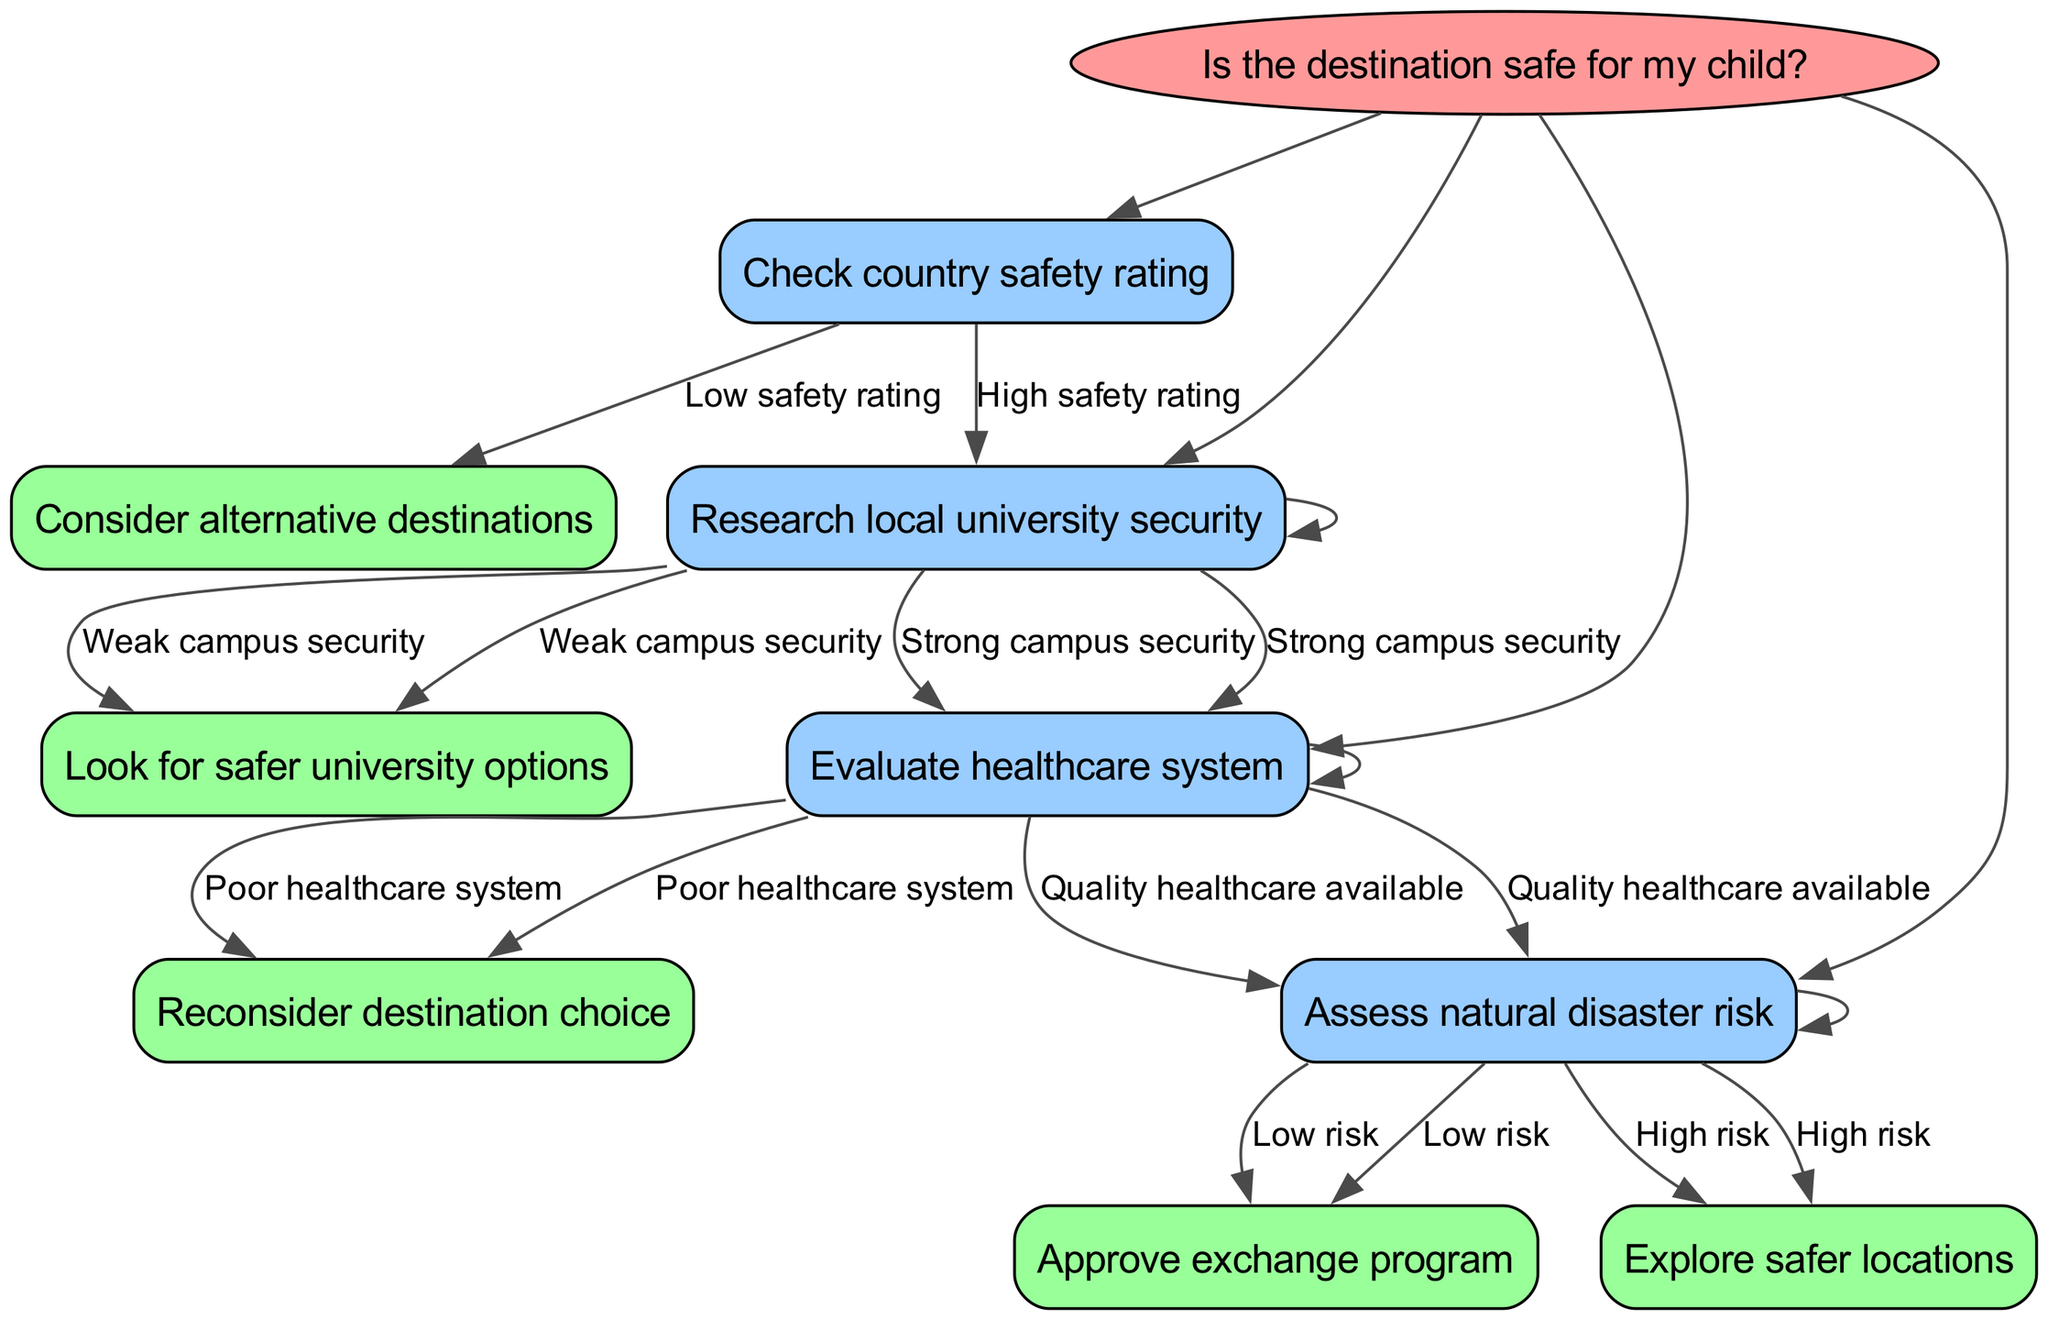What is the root node of the diagram? The root node of the diagram states, "Is the destination safe for my child?"
Answer: Is the destination safe for my child? How many branches are there from the root node? There are four branches stemming from the root node, which represent different decision points regarding safety.
Answer: Four What is the outcome if the country has a low safety rating? If the country has a low safety rating, the next node directs to "Consider alternative destinations."
Answer: Consider alternative destinations What does a strong campus security lead to in the diagram? A strong campus security leads to the next evaluation node, which is "Evaluate healthcare system."
Answer: Evaluate healthcare system What happens if the healthcare system is poor? If the healthcare system is deemed poor, the decision tree suggests "Reconsider destination choice."
Answer: Reconsider destination choice What is the final decision if there is low natural disaster risk? If there is low natural disaster risk, the outcome of the decision tree is to "Approve exchange program."
Answer: Approve exchange program If campus security is weak, what next step is recommended? If campus security is weak, the next step suggested is "Look for safer university options."
Answer: Look for safer university options In what scenario would one explore safer locations? One would explore safer locations if the assessment of natural disaster risk indicates "High risk."
Answer: High risk What type of healthcare is considered acceptable in this decision process? The decision tree considers "Quality healthcare available" as an acceptable standard in the evaluation.
Answer: Quality healthcare available 